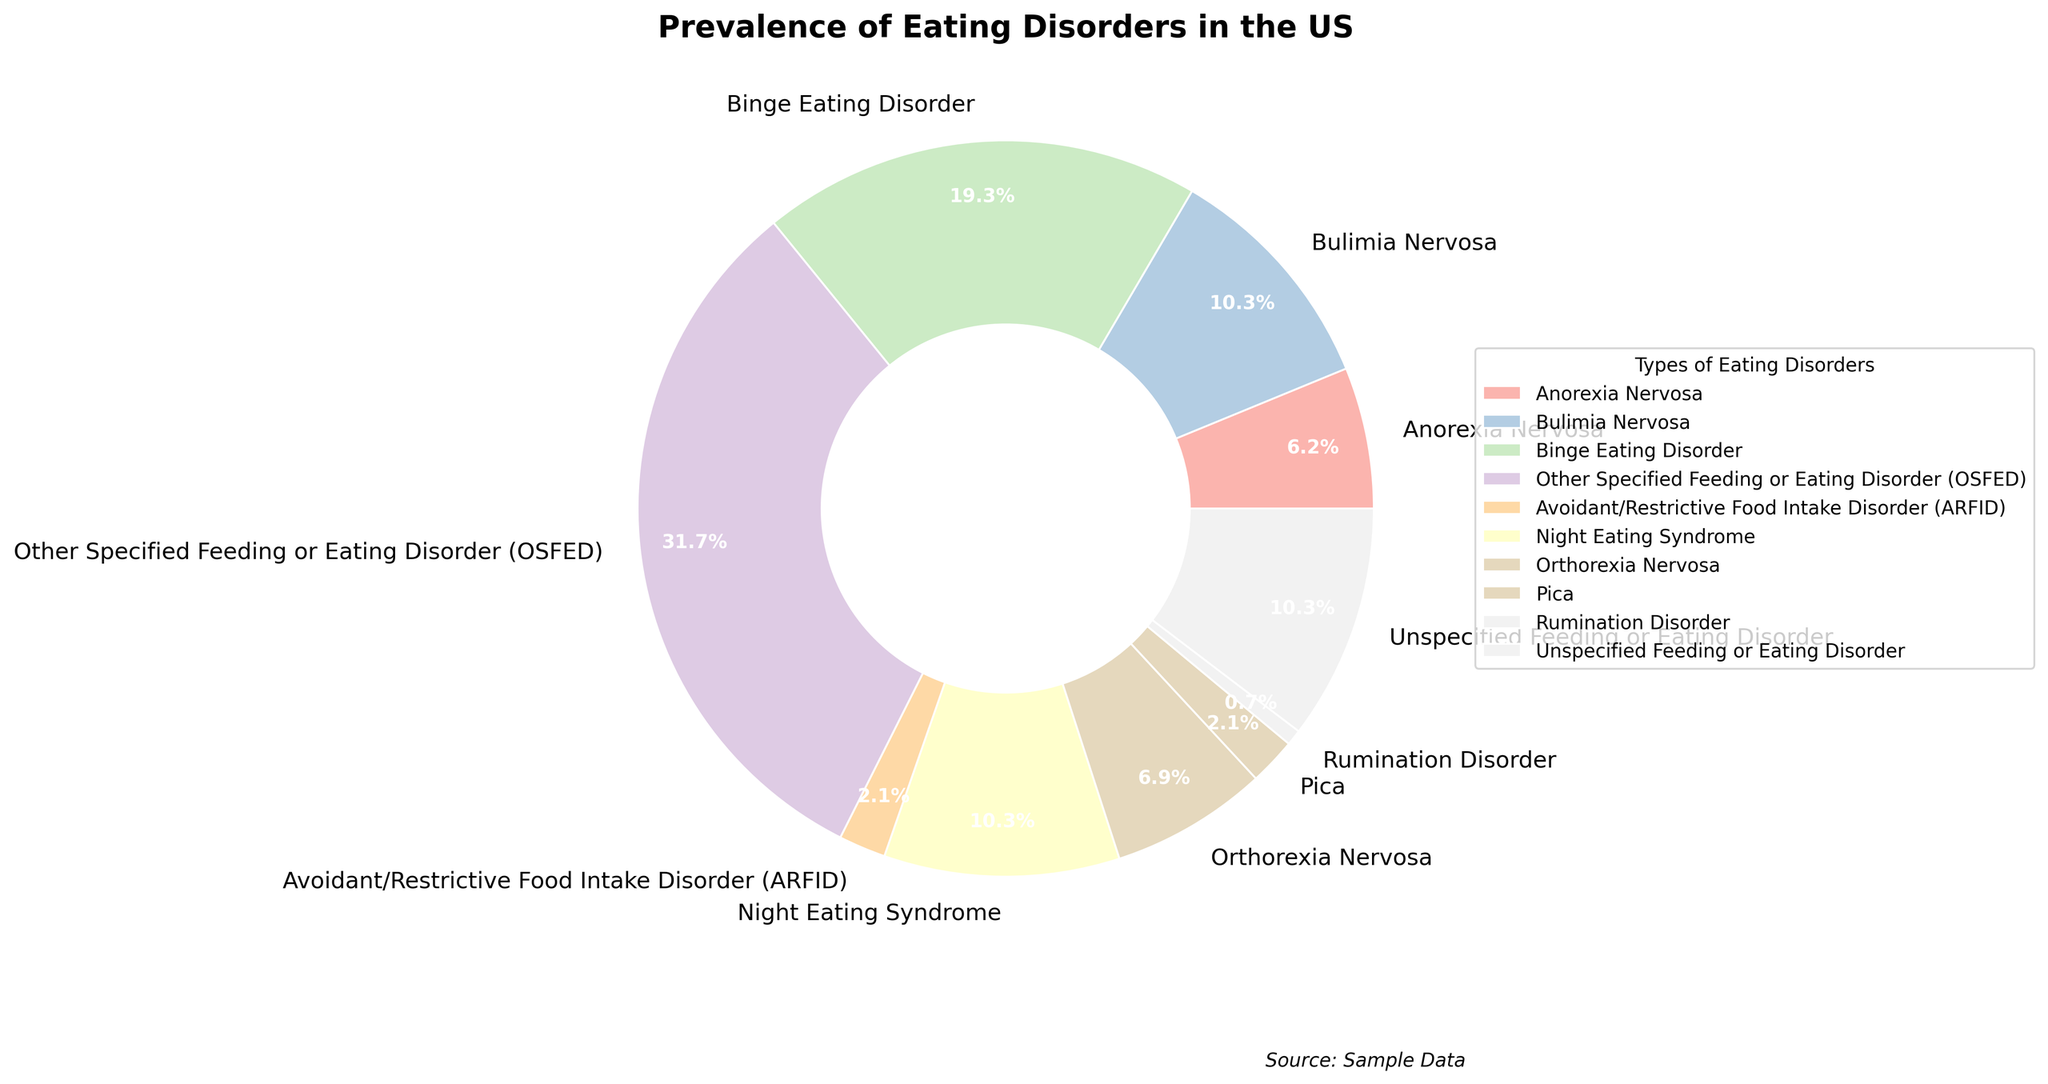What is the type of eating disorder with the highest prevalence in the US? The pie chart shows different eating disorders with their prevalence percentages labeled. By comparing the percentages, OSFED has the highest value at 4.6%.
Answer: OSFED Which types of eating disorders have the same prevalence? Night Eating Syndrome, Bulimia Nervosa, and Unspecified Feeding or Eating Disorder each show a prevalence of 1.5% on the chart.
Answer: Night Eating Syndrome, Bulimia Nervosa, Unspecified Feeding or Eating Disorder What is the total prevalence of Anorexia Nervosa and Orthorexia Nervosa combined? Add the prevalence percentages of Anorexia Nervosa (0.9%) and Orthorexia Nervosa (1.0%) together. 0.9% + 1.0% = 1.9%
Answer: 1.9% How much more prevalent is OSFED compared to Binge Eating Disorder? Subtract the prevalence of Binge Eating Disorder (2.8%) from OSFED (4.6%). 4.6% - 2.8% = 1.8%
Answer: 1.8% What proportion of the total prevalence is contributed by Pica and Rumination Disorder together? Add the prevalences of Pica (0.3%) and Rumination Disorder (0.1%) first, then find the proportion relative to the total prevalence. The total prevalence of all disorders is the sum of their individual percentages: 0.9 + 1.5 + 2.8 + 4.6 + 0.3 + 1.5 + 1.0 + 0.3 + 0.1 + 1.5 = 14.5%. Proportion = (0.3% + 0.1%) / 14.5% = 0.4% / 14.5% ≈ 0.0276 or 2.76%.
Answer: 2.76% Which type of eating disorder has more prevalence: Binge Eating Disorder or all eating disorders with less than 1% prevalence combined? First, note disorders less than 1%: Anorexia (0.9%), ARFID (0.3%), Pica (0.3%), Rumination Disorder (0.1%). Sum these: 0.9% + 0.3% + 0.3% + 0.1% = 1.6%. Binge Eating Disorder is 2.8%. 2.8% is greater than 1.6%.
Answer: Binge Eating Disorder Which type of eating disorder has the lowest prevalence and what is its percentage? The pie chart indicates Rumination Disorder has the lowest prevalence of 0.1%.
Answer: Rumination Disorder, 0.1% Rank the top three eating disorders by prevalence. By examining the pie chart, we can see that the top three are OSFED (4.6%), Binge Eating Disorder (2.8%), and Night Eating Syndrome/Bulimia Nervosa/Unspecified Feeding or Eating Disorder (all at 1.5%).
Answer: OSFED, Binge Eating Disorder, Night Eating Syndrome/Bulimia Nervosa/Unspecified Feeding or Eating Disorder 